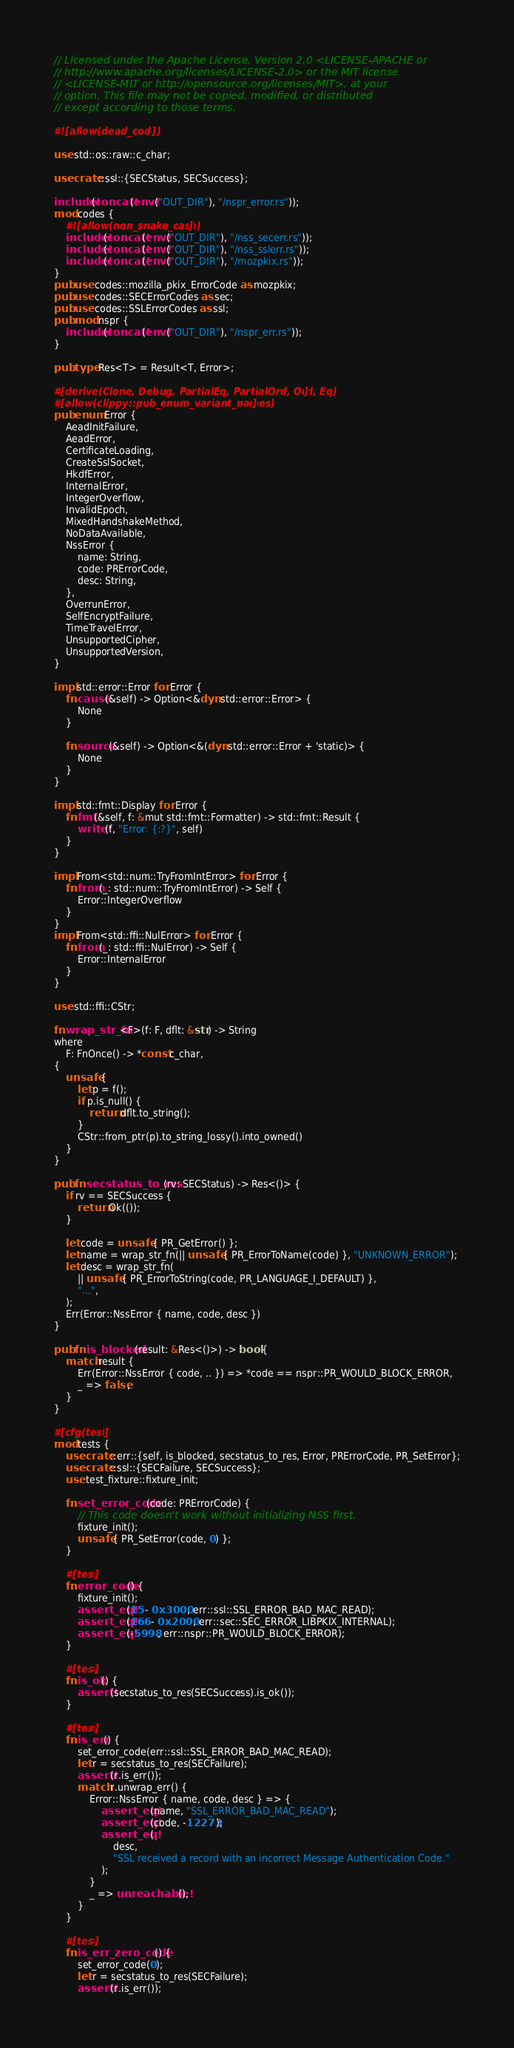Convert code to text. <code><loc_0><loc_0><loc_500><loc_500><_Rust_>// Licensed under the Apache License, Version 2.0 <LICENSE-APACHE or
// http://www.apache.org/licenses/LICENSE-2.0> or the MIT license
// <LICENSE-MIT or http://opensource.org/licenses/MIT>, at your
// option. This file may not be copied, modified, or distributed
// except according to those terms.

#![allow(dead_code)]

use std::os::raw::c_char;

use crate::ssl::{SECStatus, SECSuccess};

include!(concat!(env!("OUT_DIR"), "/nspr_error.rs"));
mod codes {
    #![allow(non_snake_case)]
    include!(concat!(env!("OUT_DIR"), "/nss_secerr.rs"));
    include!(concat!(env!("OUT_DIR"), "/nss_sslerr.rs"));
    include!(concat!(env!("OUT_DIR"), "/mozpkix.rs"));
}
pub use codes::mozilla_pkix_ErrorCode as mozpkix;
pub use codes::SECErrorCodes as sec;
pub use codes::SSLErrorCodes as ssl;
pub mod nspr {
    include!(concat!(env!("OUT_DIR"), "/nspr_err.rs"));
}

pub type Res<T> = Result<T, Error>;

#[derive(Clone, Debug, PartialEq, PartialOrd, Ord, Eq)]
#[allow(clippy::pub_enum_variant_names)]
pub enum Error {
    AeadInitFailure,
    AeadError,
    CertificateLoading,
    CreateSslSocket,
    HkdfError,
    InternalError,
    IntegerOverflow,
    InvalidEpoch,
    MixedHandshakeMethod,
    NoDataAvailable,
    NssError {
        name: String,
        code: PRErrorCode,
        desc: String,
    },
    OverrunError,
    SelfEncryptFailure,
    TimeTravelError,
    UnsupportedCipher,
    UnsupportedVersion,
}

impl std::error::Error for Error {
    fn cause(&self) -> Option<&dyn std::error::Error> {
        None
    }

    fn source(&self) -> Option<&(dyn std::error::Error + 'static)> {
        None
    }
}

impl std::fmt::Display for Error {
    fn fmt(&self, f: &mut std::fmt::Formatter) -> std::fmt::Result {
        write!(f, "Error: {:?}", self)
    }
}

impl From<std::num::TryFromIntError> for Error {
    fn from(_: std::num::TryFromIntError) -> Self {
        Error::IntegerOverflow
    }
}
impl From<std::ffi::NulError> for Error {
    fn from(_: std::ffi::NulError) -> Self {
        Error::InternalError
    }
}

use std::ffi::CStr;

fn wrap_str_fn<F>(f: F, dflt: &str) -> String
where
    F: FnOnce() -> *const c_char,
{
    unsafe {
        let p = f();
        if p.is_null() {
            return dflt.to_string();
        }
        CStr::from_ptr(p).to_string_lossy().into_owned()
    }
}

pub fn secstatus_to_res(rv: SECStatus) -> Res<()> {
    if rv == SECSuccess {
        return Ok(());
    }

    let code = unsafe { PR_GetError() };
    let name = wrap_str_fn(|| unsafe { PR_ErrorToName(code) }, "UNKNOWN_ERROR");
    let desc = wrap_str_fn(
        || unsafe { PR_ErrorToString(code, PR_LANGUAGE_I_DEFAULT) },
        "...",
    );
    Err(Error::NssError { name, code, desc })
}

pub fn is_blocked(result: &Res<()>) -> bool {
    match result {
        Err(Error::NssError { code, .. }) => *code == nspr::PR_WOULD_BLOCK_ERROR,
        _ => false,
    }
}

#[cfg(test)]
mod tests {
    use crate::err::{self, is_blocked, secstatus_to_res, Error, PRErrorCode, PR_SetError};
    use crate::ssl::{SECFailure, SECSuccess};
    use test_fixture::fixture_init;

    fn set_error_code(code: PRErrorCode) {
        // This code doesn't work without initializing NSS first.
        fixture_init();
        unsafe { PR_SetError(code, 0) };
    }

    #[test]
    fn error_code() {
        fixture_init();
        assert_eq!(15 - 0x3000, err::ssl::SSL_ERROR_BAD_MAC_READ);
        assert_eq!(166 - 0x2000, err::sec::SEC_ERROR_LIBPKIX_INTERNAL);
        assert_eq!(-5998, err::nspr::PR_WOULD_BLOCK_ERROR);
    }

    #[test]
    fn is_ok() {
        assert!(secstatus_to_res(SECSuccess).is_ok());
    }

    #[test]
    fn is_err() {
        set_error_code(err::ssl::SSL_ERROR_BAD_MAC_READ);
        let r = secstatus_to_res(SECFailure);
        assert!(r.is_err());
        match r.unwrap_err() {
            Error::NssError { name, code, desc } => {
                assert_eq!(name, "SSL_ERROR_BAD_MAC_READ");
                assert_eq!(code, -12273);
                assert_eq!(
                    desc,
                    "SSL received a record with an incorrect Message Authentication Code."
                );
            }
            _ => unreachable!(),
        }
    }

    #[test]
    fn is_err_zero_code() {
        set_error_code(0);
        let r = secstatus_to_res(SECFailure);
        assert!(r.is_err());</code> 